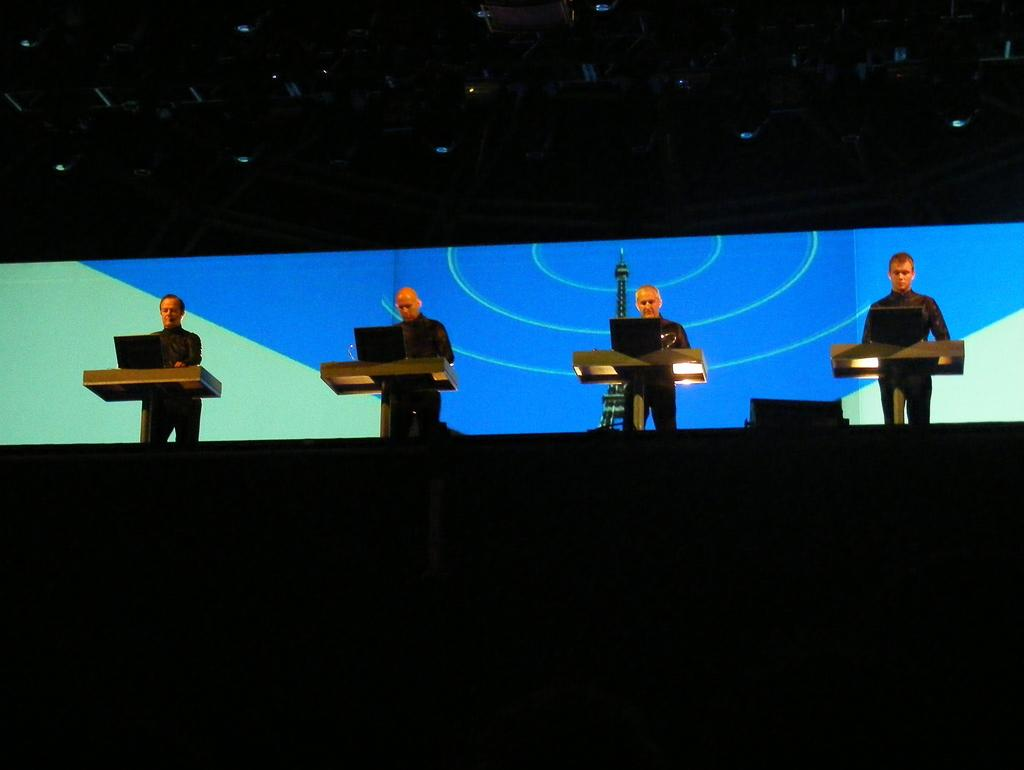How many people are in the image? There are four men in the image. What are the men doing in the image? The men are standing at a podium. What objects are on the podiums? There is a laptop on each podium. What famous landmark can be seen in the background of the image? The Eiffel Tower is in the background of the image. What type of screw can be seen holding the wax arch together in the image? There is no screw or wax arch present in the image; it features four men standing at podiums with laptops and the Eiffel Tower in the background. 